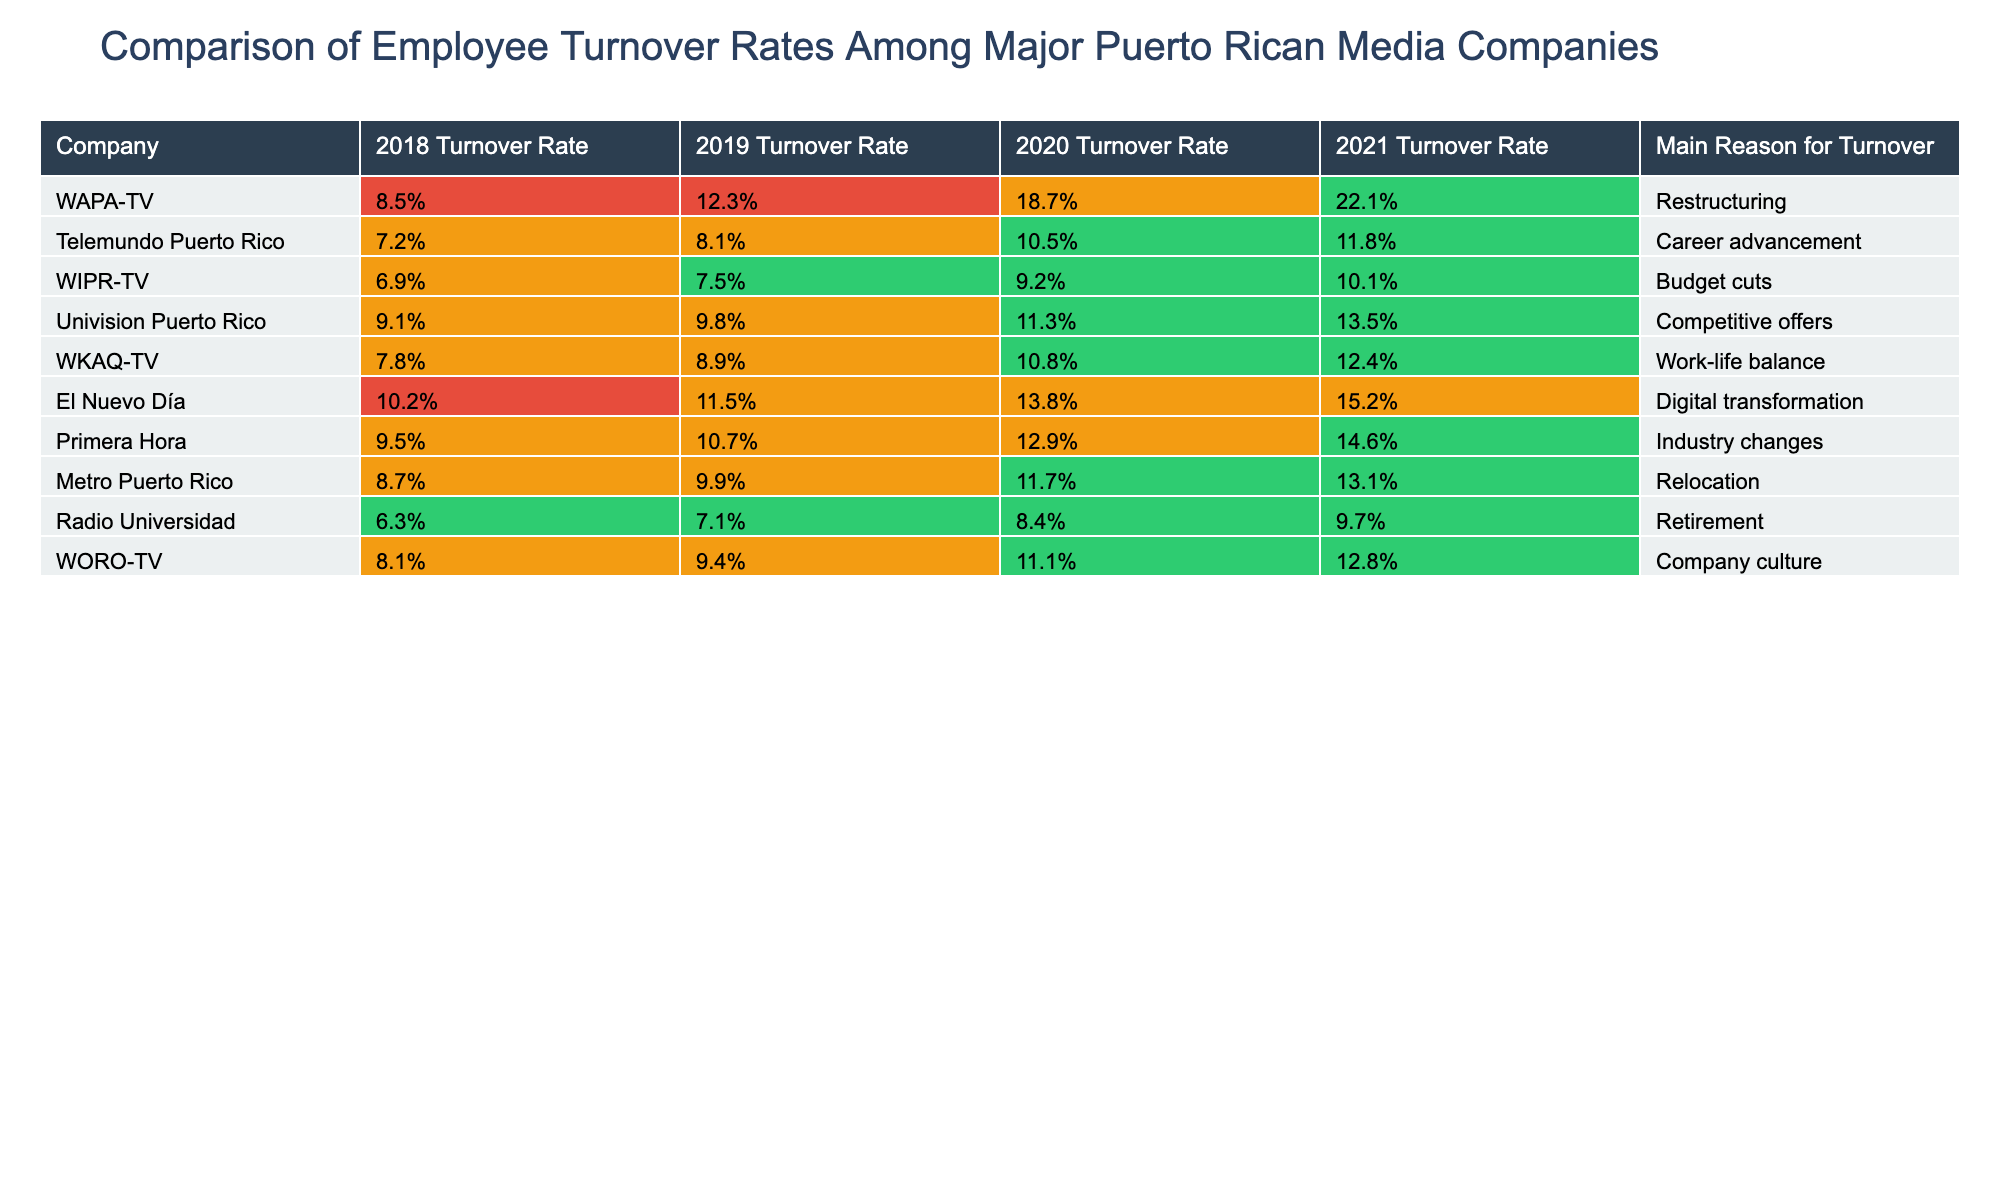What was WAPA-TV's turnover rate in 2021? According to the table, WAPA-TV's turnover rate in 2021 is shown in the '2021 Turnover Rate' column of its respective row, which is 22.1%.
Answer: 22.1% Which company had the highest turnover rate in 2020? To identify the highest turnover rate in 2020, we look at the values listed in the '2020 Turnover Rate' column and find the maximum value. WAPA-TV has the highest rate at 18.7%.
Answer: WAPA-TV What is the average turnover rate for Telemundo Puerto Rico from 2018 to 2021? We first sum the turnover rates for Telemundo Puerto Rico across the four years: 7.2% + 8.1% + 10.5% + 11.8% = 37.6%. Then we divide by 4 for the average: 37.6% / 4 = 9.4%.
Answer: 9.4% Did Radio Universidad have a higher turnover rate than WIPR-TV in 2021? In the table, we compare the '2021 Turnover Rate' values for Radio Universidad (9.7%) and WIPR-TV (10.1%). Since 9.7% is less than 10.1%, Radio Universidad did not have a higher turnover rate.
Answer: No What was the trend in turnover rates for El Nuevo Día from 2018 to 2021? By observing the values in the '2018 Turnover Rate' (10.2%), '2019 Turnover Rate' (11.5%), '2020 Turnover Rate' (13.8%), and '2021 Turnover Rate' (15.2%), we see that the turnover rate increased each year. Thus, the trend was upward.
Answer: Increasing 